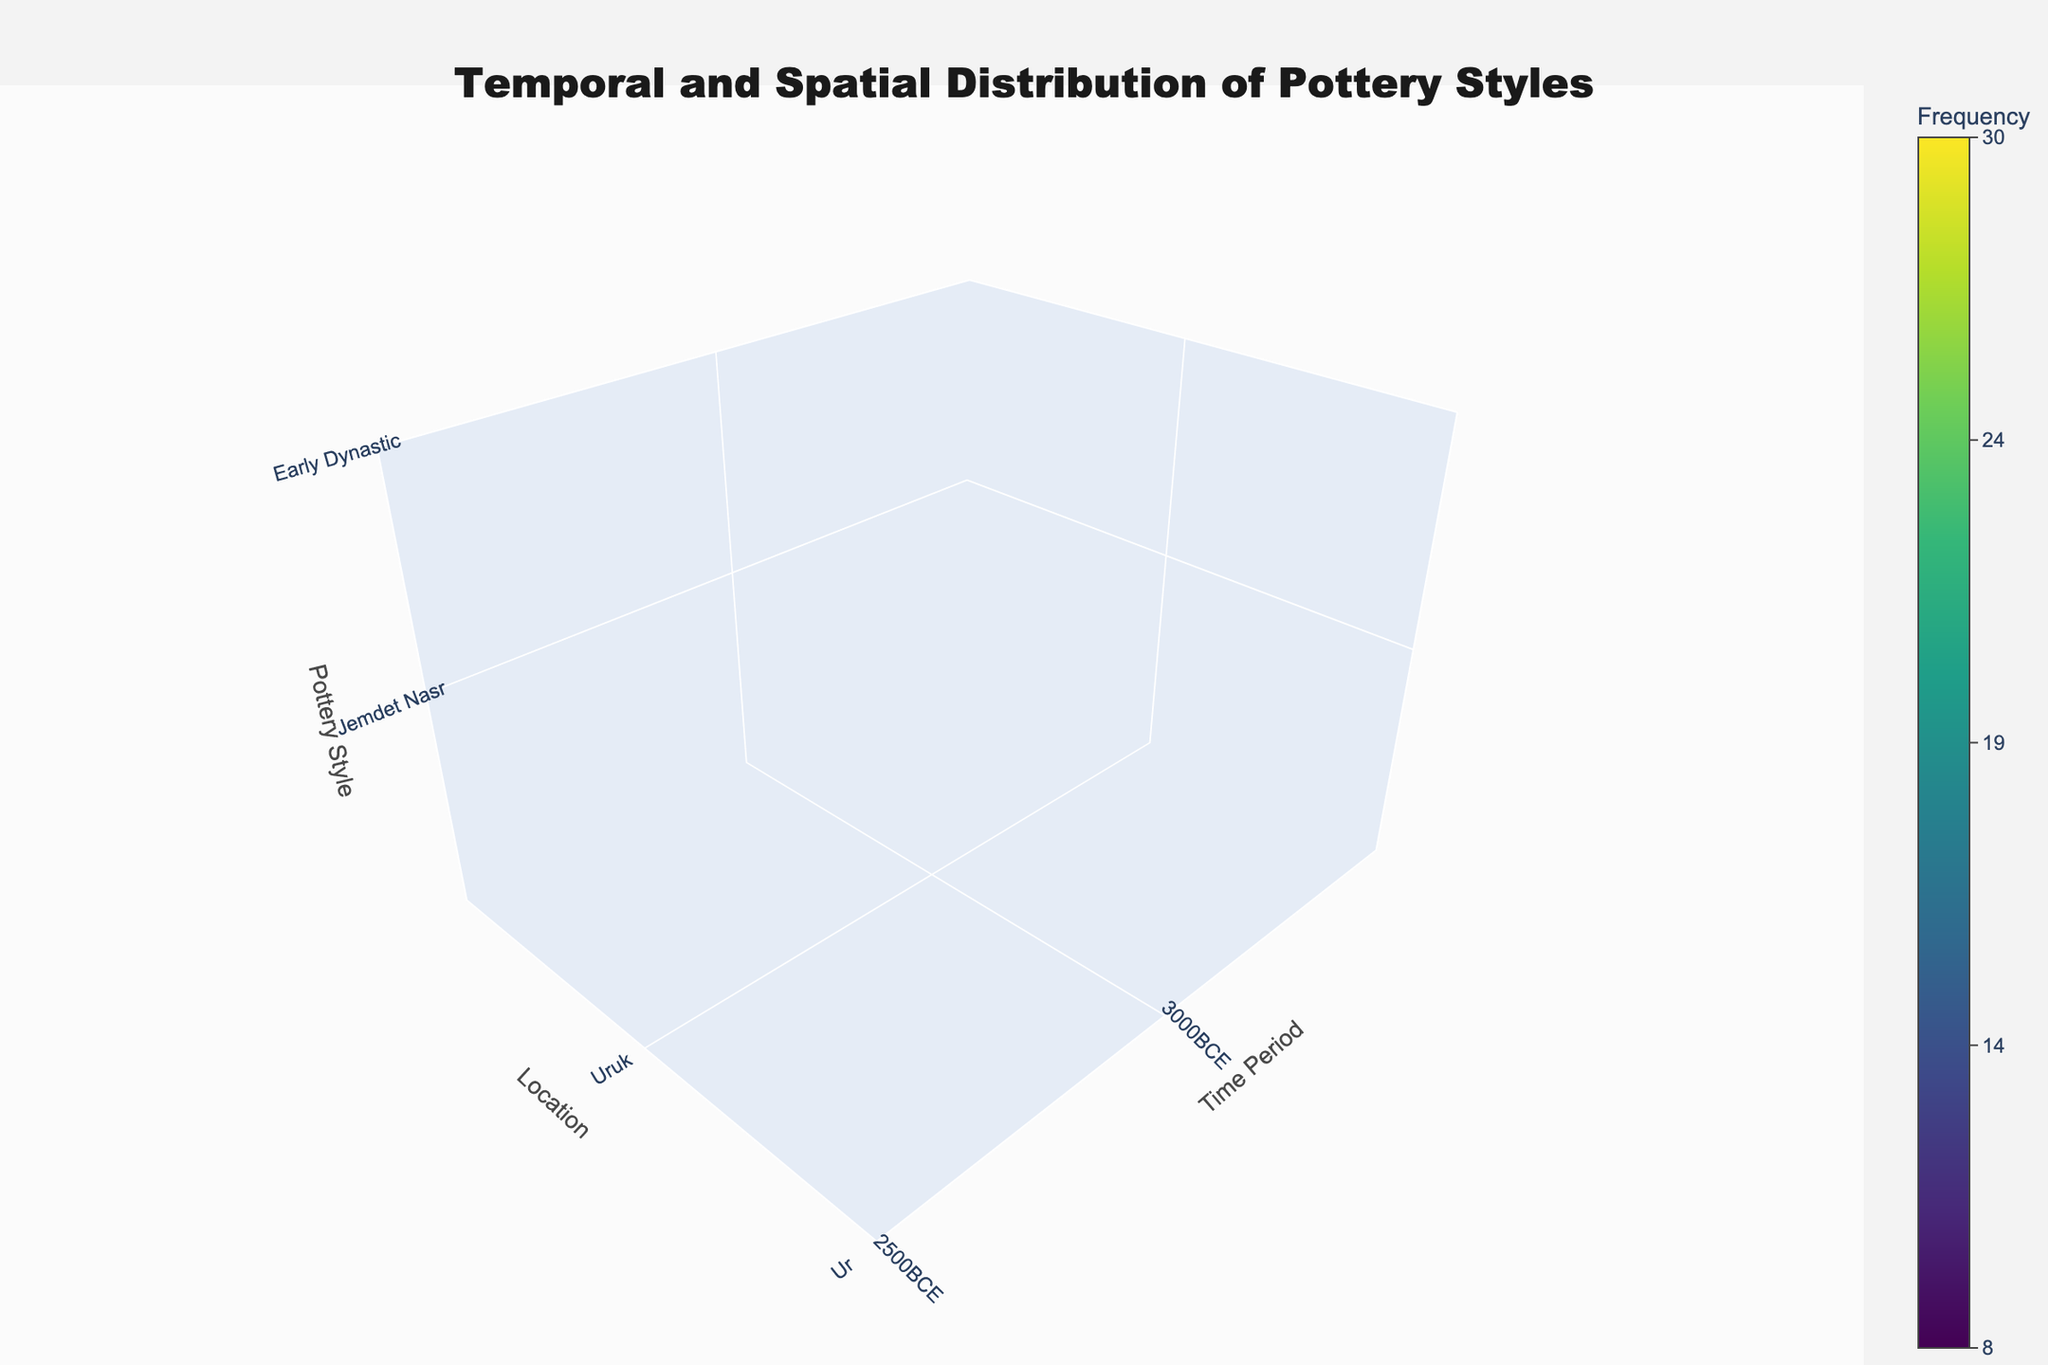How many time periods are represented in the plot? To determine the number of time periods, identify the unique values along the Time Period axis. There are 5 distinct time periods visible in the plot (3000BCE, 2500BCE, 2000BCE, 1500BCE, 1000BCE).
Answer: 5 Which location has the highest frequency of Jemdet Nasr pottery styles in the plot? Look at the Time Period axis for the value '3000BCE' and check each appropriate location's frequency values. Uruk has the highest frequency (15) for Jemdet Nasr at this time period.
Answer: Uruk What is the average frequency of pottery styles found at Ur? Sum the frequency values for Ur across all time periods (12 + 25 + 28 + 15 + 8) and divide by the number of time periods (5). The total is 88, and the average is 88/5 = 17.6.
Answer: 17.6 During which time period was the Isin-Larsa pottery style most frequent at Uruk? Check the Time Period axis for '2000BCE' and identify the frequency value for the Isin-Larsa pottery style at Uruk. It shows a frequency value of 30 during this period.
Answer: 2000BCE Are there any time periods where Nippur has a higher frequency of pottery styles than both Ur and Uruk? Compare frequency values for each time period. In 1500BCE, Nippur has a pottery style frequency of 22, while Uruk and Ur have frequencies of 18 and 15, respectively, indicating a higher frequency for Nippur.
Answer: Yes, in 1500BCE How does the frequency of Kassite pottery styles compare between Ur and Nippur? Observe the frequency values for Kassite pottery styles for both locations. Ur has a frequency of 15, while Nippur has a frequency of 22. Nippur's frequency is higher.
Answer: Nippur has a higher frequency What is the trend in the frequency of pottery styles at Uruk over time? Analyze the frequency values at Uruk for each time period. The trend shows increasing, decreasing, or stable changes. Uruk's frequencies are 15, 22, 30, 18, and 10 over five time periods, indicating an initial increase, a peak, and then a decline.
Answer: Initial increase, then decline Which pottery style is most frequent in 2000BCE across all locations? Sum each pottery style's frequency across all locations for 2000BCE. Jemdet Nasr: 0, Early Dynastic: 0, Isin-Larsa: 30+28+20 = 78, Kassite: 0, Neo-Assyrian: 0. Isin-Larsa has the highest frequency (78).
Answer: Isin-Larsa In which time periods did the frequency of Neo-Assyrian pottery styles decrease at Uruk? Identify the specific frequency values of Neo-Assyrian pottery styles at Uruk over different time periods, and note the decreases. There is only one record for Neo-Assyrian pottery (10 in 1000BCE), so there's no preceding value for comparison. Therefore, the frequency has only been documented in 1000BCE.
Answer: Only in 1000BCE What is the total number of pottery styles recorded at Nippur? Count the distinct pottery styles recorded at Nippur over all the periods: Jemdet Nasr, Early Dynastic, Isin-Larsa, Kassite, and Neo-Assyrian.
Answer: 5 